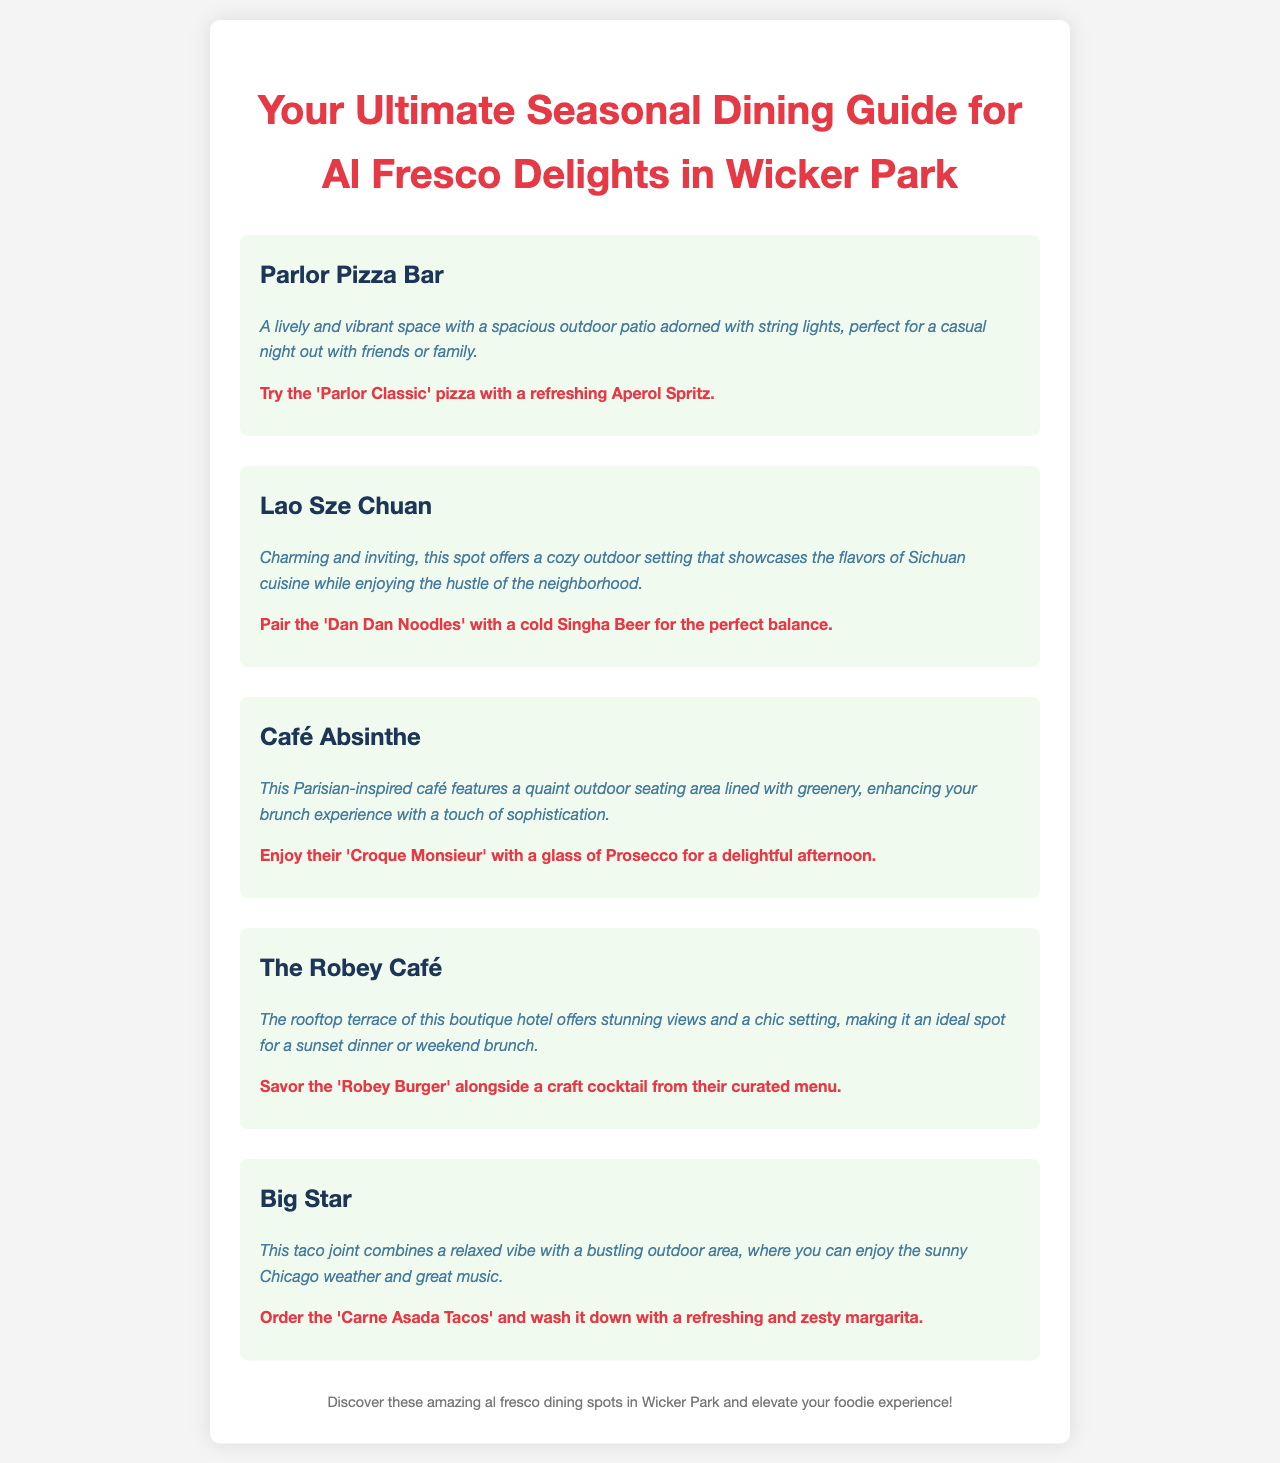What is the title of the guide? The title of the guide provides the main focus and theme, which is about seasonal dining in Wicker Park.
Answer: Your Ultimate Seasonal Dining Guide for Al Fresco Delights in Wicker Park How many restaurants are mentioned? The document lists a specific number of restaurants that offer al fresco dining experiences in Wicker Park.
Answer: Five What is the ambiance description for Parlor Pizza Bar? The ambiance description for Parlor Pizza Bar highlights the outdoor space and its atmosphere.
Answer: A lively and vibrant space with a spacious outdoor patio adorned with string lights, perfect for a casual night out with friends or family Which pairing is suggested for Cafe Absinthe? The suggested pairing is specific to one of the menu items and a beverage that complements it at Cafe Absinthe.
Answer: Enjoy their 'Croque Monsieur' with a glass of Prosecco for a delightful afternoon What type of setting does The Robey Café offer? This question inquires about the specific atmosphere and experience at The Robey Café based on its description in the document.
Answer: The rooftop terrace of this boutique hotel offers stunning views and a chic setting Which drink is recommended with Big Star's Carne Asada Tacos? The document provides a specific drink pairing for a food item at Big Star, highlighting its refreshing nature.
Answer: A refreshing and zesty margarita 